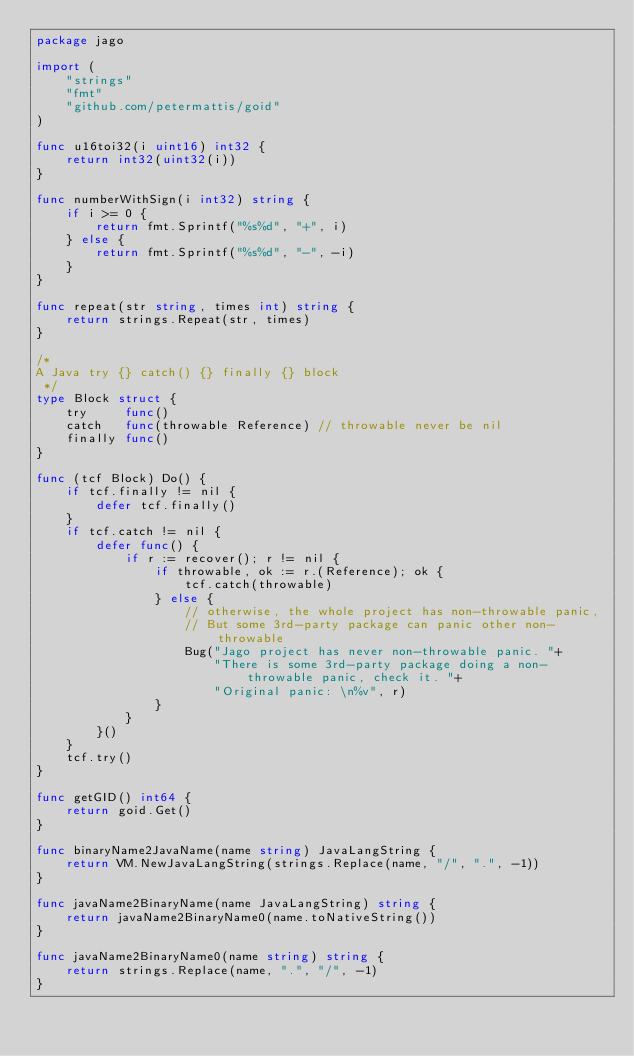<code> <loc_0><loc_0><loc_500><loc_500><_Go_>package jago

import (
	"strings"
	"fmt"
	"github.com/petermattis/goid"
)

func u16toi32(i uint16) int32 {
	return int32(uint32(i))
}

func numberWithSign(i int32) string {
	if i >= 0 {
		return fmt.Sprintf("%s%d", "+", i)
	} else {
		return fmt.Sprintf("%s%d", "-", -i)
	}
}

func repeat(str string, times int) string {
	return strings.Repeat(str, times)
}

/*
A Java try {} catch() {} finally {} block
 */
type Block struct {
	try     func()
	catch   func(throwable Reference) // throwable never be nil
	finally func()
}

func (tcf Block) Do() {
	if tcf.finally != nil {
		defer tcf.finally()
	}
	if tcf.catch != nil {
		defer func() {
			if r := recover(); r != nil {
				if throwable, ok := r.(Reference); ok {
					tcf.catch(throwable)
				} else {
					// otherwise, the whole project has non-throwable panic,
					// But some 3rd-party package can panic other non-throwable
					Bug("Jago project has never non-throwable panic. "+
						"There is some 3rd-party package doing a non-throwable panic, check it. "+
						"Original panic: \n%v", r)
				}
			}
		}()
	}
	tcf.try()
}

func getGID() int64 {
	return goid.Get()
}

func binaryName2JavaName(name string) JavaLangString {
	return VM.NewJavaLangString(strings.Replace(name, "/", ".", -1))
}

func javaName2BinaryName(name JavaLangString) string {
	return javaName2BinaryName0(name.toNativeString())
}

func javaName2BinaryName0(name string) string {
	return strings.Replace(name, ".", "/", -1)
}
</code> 